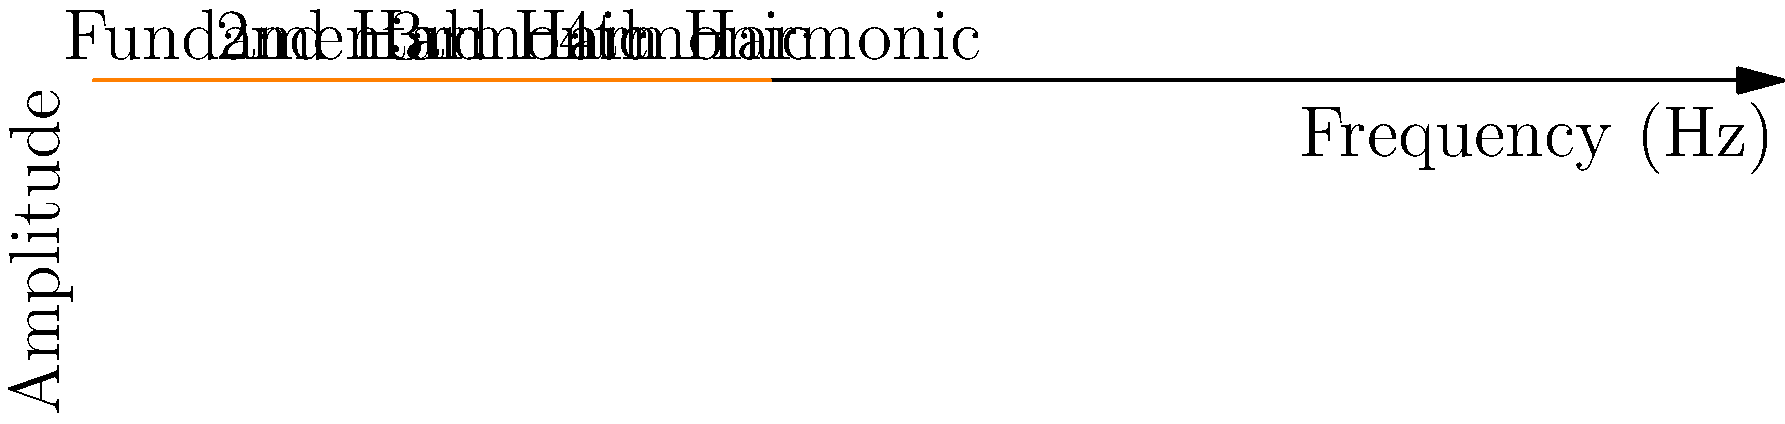A spectrogram of a musical note is shown above. If the fundamental frequency is 1000 Hz, what is the frequency of the 3rd harmonic? To find the frequency of the 3rd harmonic, we need to understand the relationship between harmonics and the fundamental frequency:

1. The fundamental frequency is the first and lowest frequency in a harmonic series.
2. Harmonics are integer multiples of the fundamental frequency.
3. The 2nd harmonic is twice the fundamental frequency, the 3rd harmonic is three times the fundamental frequency, and so on.

Given:
- The fundamental frequency is 1000 Hz.
- We need to find the 3rd harmonic.

Step 1: Determine the relationship between the 3rd harmonic and the fundamental frequency.
The 3rd harmonic is 3 times the fundamental frequency.

Step 2: Calculate the frequency of the 3rd harmonic.
3rd harmonic = 3 × fundamental frequency
3rd harmonic = 3 × 1000 Hz = 3000 Hz

Therefore, the frequency of the 3rd harmonic is 3000 Hz.
Answer: 3000 Hz 